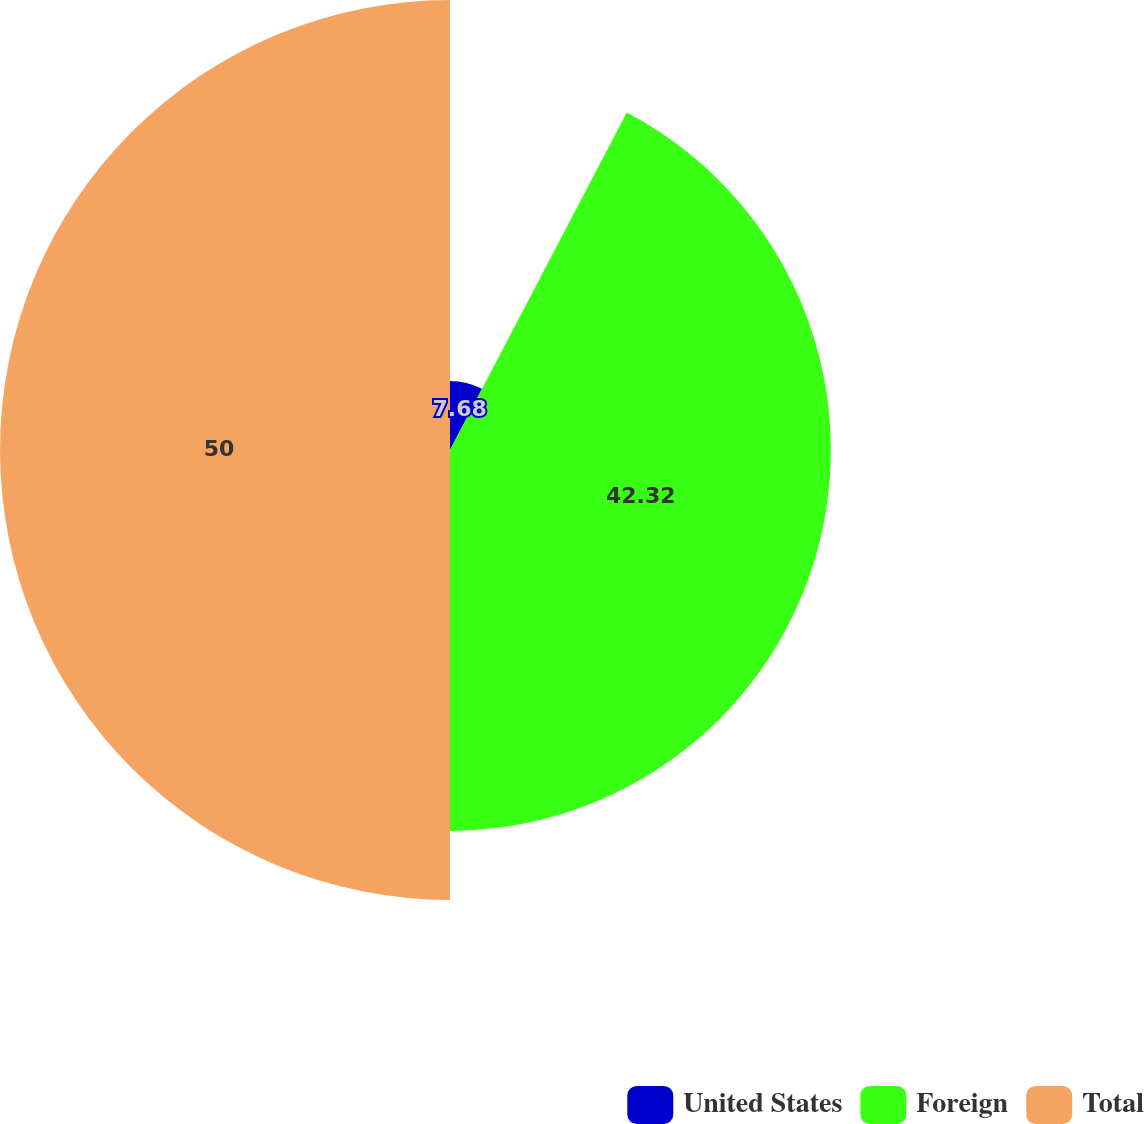Convert chart to OTSL. <chart><loc_0><loc_0><loc_500><loc_500><pie_chart><fcel>United States<fcel>Foreign<fcel>Total<nl><fcel>7.68%<fcel>42.32%<fcel>50.0%<nl></chart> 